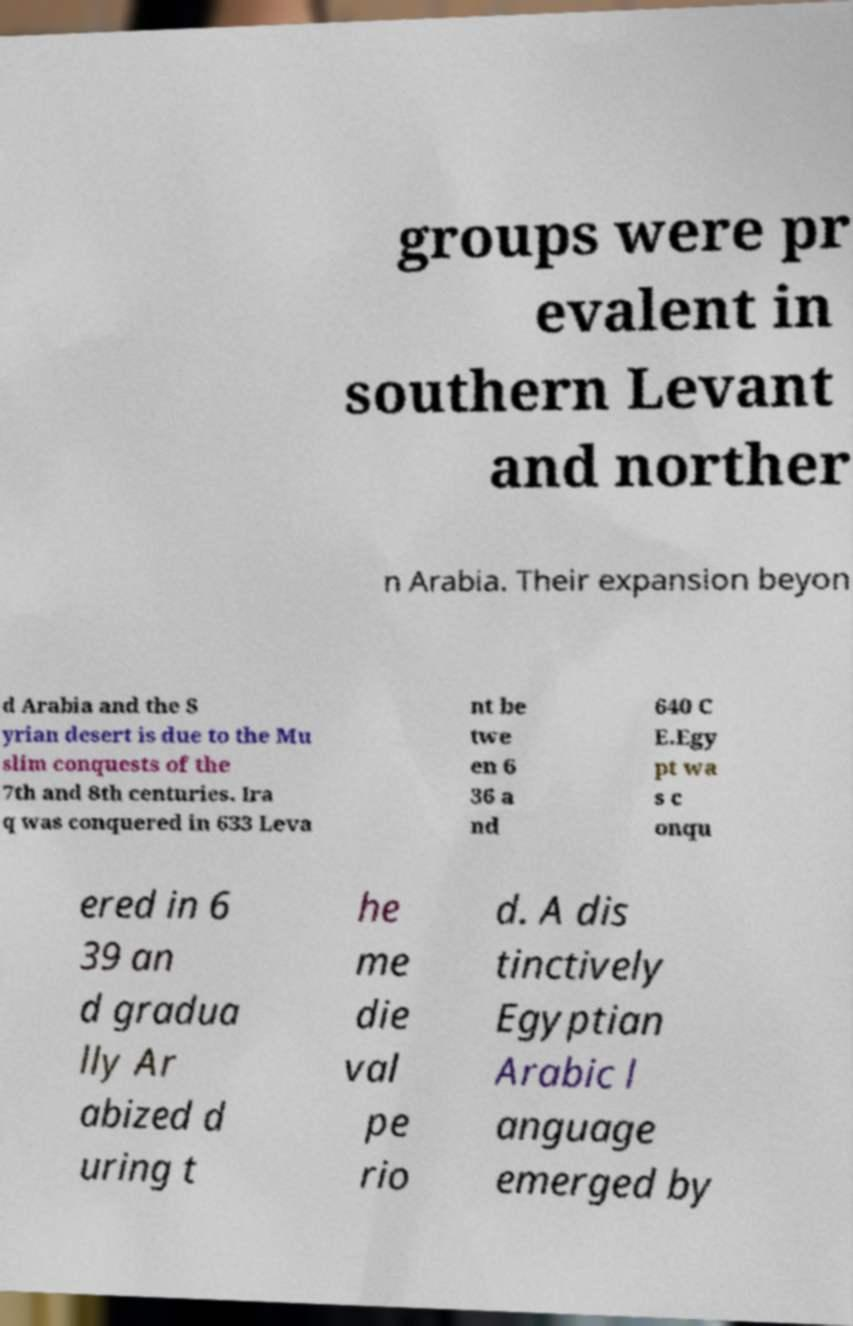Can you accurately transcribe the text from the provided image for me? groups were pr evalent in southern Levant and norther n Arabia. Their expansion beyon d Arabia and the S yrian desert is due to the Mu slim conquests of the 7th and 8th centuries. Ira q was conquered in 633 Leva nt be twe en 6 36 a nd 640 C E.Egy pt wa s c onqu ered in 6 39 an d gradua lly Ar abized d uring t he me die val pe rio d. A dis tinctively Egyptian Arabic l anguage emerged by 